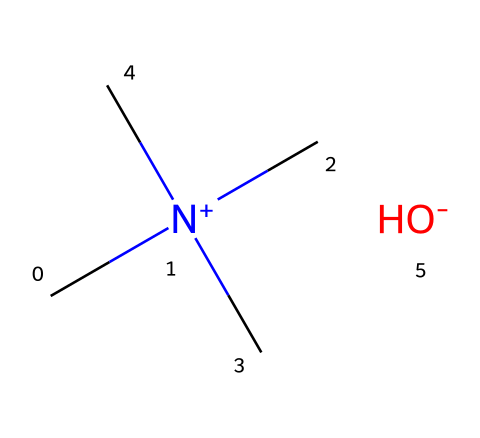What is the name of this chemical? The provided SMILES representation corresponds to tetramethylammonium hydroxide. The presence of the nitrogen atom bonded to four methyl groups and the hydroxide group confirms its identity.
Answer: tetramethylammonium hydroxide How many carbon atoms are in this molecule? The structural formula indicates that there are four methyl groups (each containing one carbon atom), leading to a total of four carbon atoms in the molecule.
Answer: 4 What type of ion is present in this chemical structure? The presence of the hydroxide group (OH-) indicates the presence of a hydroxide ion, which is a negatively charged ion.
Answer: hydroxide ion How many hydrogen atoms are connected to the nitrogen atom? Each methyl group (four total) contributes three hydrogen atoms, and since the nitrogen is bonded to four carbons, it does not have additional hydrogen atoms attached directly. Therefore, the nitrogen does not have any additional hydrogen associated with it.
Answer: 0 Why is tetramethylammonium hydroxide considered a superbase? The structure shows that it contains a quaternary ammonium salt configuration, which, combined with the strong basicity of the hydroxide ion, gives it superbase characteristics. Superbases have very strong basic properties compared to typical bases due to their ability to abstract protons effectively.
Answer: strong basicity What are the total number of atoms in this molecule? Counting the atoms, we find 4 carbons, 12 hydrogens, 1 nitrogen, and 1 oxygen: 4 + 12 + 1 + 1 = 18 atoms in total.
Answer: 18 